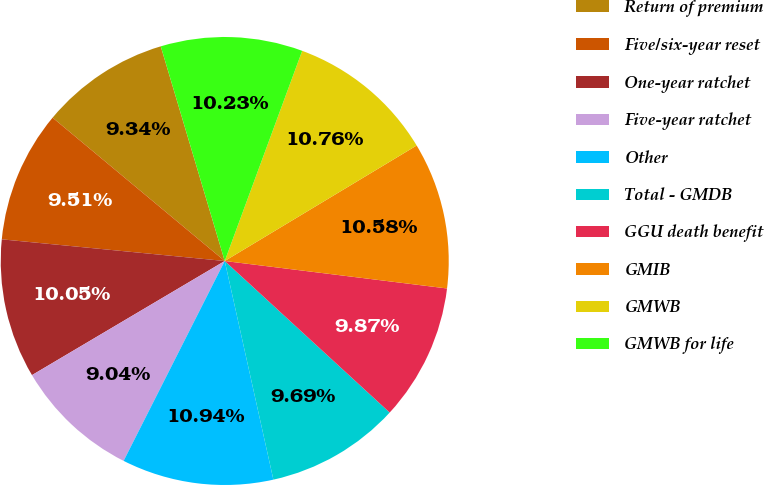Convert chart. <chart><loc_0><loc_0><loc_500><loc_500><pie_chart><fcel>Return of premium<fcel>Five/six-year reset<fcel>One-year ratchet<fcel>Five-year ratchet<fcel>Other<fcel>Total - GMDB<fcel>GGU death benefit<fcel>GMIB<fcel>GMWB<fcel>GMWB for life<nl><fcel>9.34%<fcel>9.51%<fcel>10.05%<fcel>9.04%<fcel>10.94%<fcel>9.69%<fcel>9.87%<fcel>10.58%<fcel>10.76%<fcel>10.23%<nl></chart> 